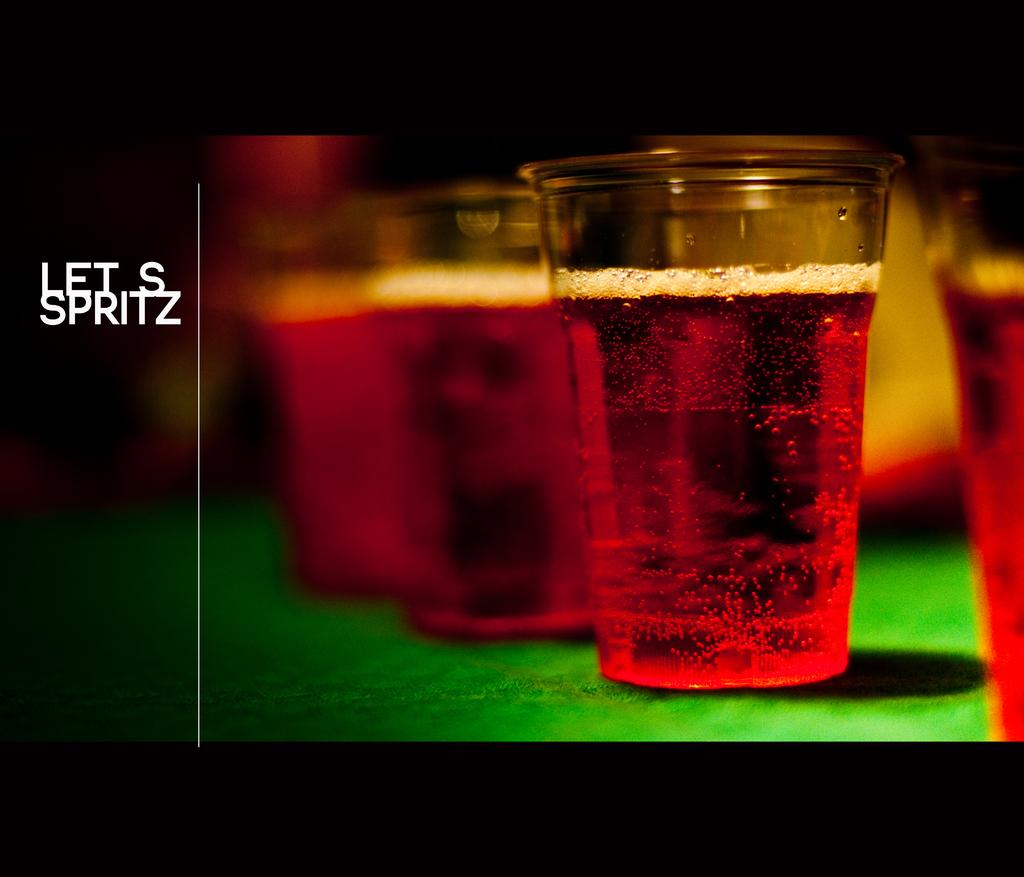What is contained in the glasses that are visible in the image? There are glasses with liquid in the image. What color is the object that can be seen in the image? There is a green color object in the image. What can be read or seen in the form of words in the image? There is text visible in the image. How many cows are present in the image? There are no cows present in the image. What is the starting point for the text visible in the image? The provided facts do not mention a starting point for the text, so it cannot be determined from the information given. 